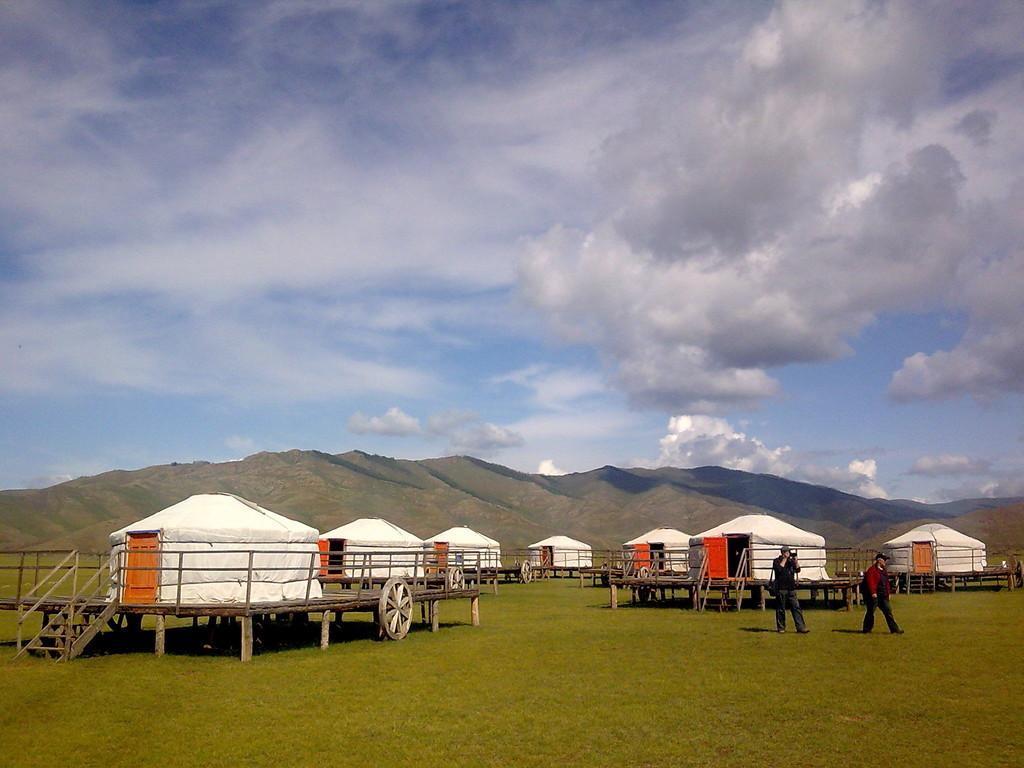What type of structures can be seen in the image? There are houses in the image. How many people are present in the image? There are two persons in the image. What are the persons doing in the image? The persons are walking on the grass. What can be seen in the distance in the image? There are hills visible in the background of the image. What is visible in the sky in the image? There are clouds in the background of the image. Can you see a snake slithering through the grass in the image? There is no snake visible in the image; the persons are walking on the grass. Where is the library located in the image? There is no library present in the image. 